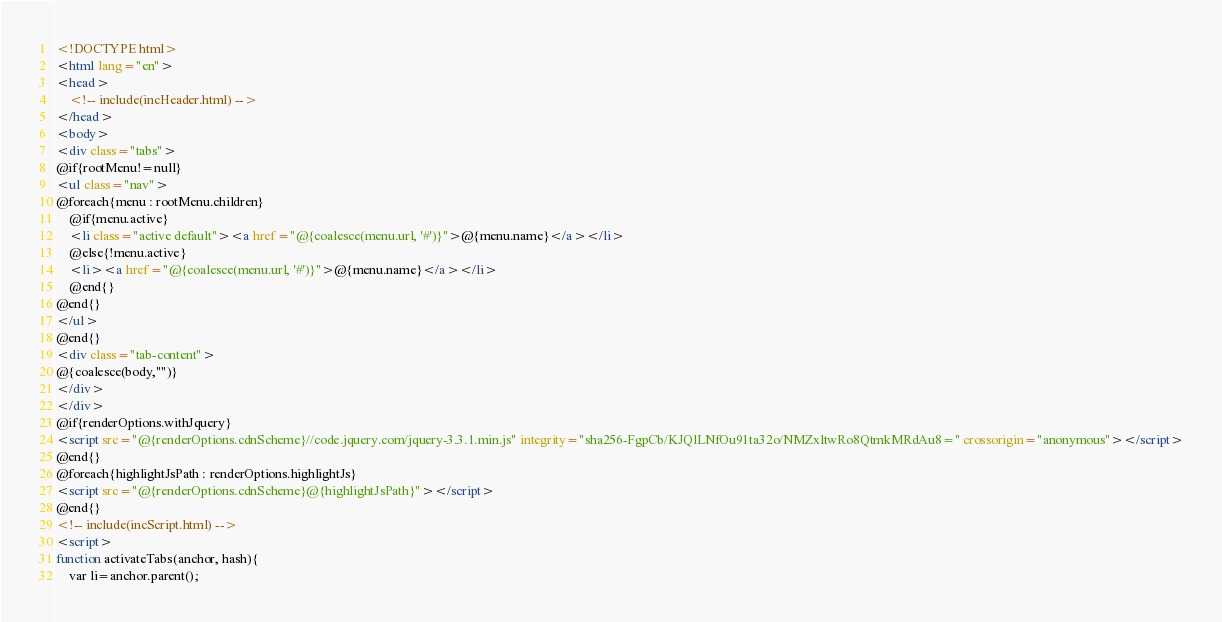Convert code to text. <code><loc_0><loc_0><loc_500><loc_500><_HTML_><!DOCTYPE html>
<html lang="en">
<head>
	<!-- include(incHeader.html) -->
</head>
<body>
<div class="tabs">
@if{rootMenu!=null}
<ul class="nav">
@foreach{menu : rootMenu.children}
	@if{menu.active}
	<li class="active default"><a href="@{coalesce(menu.url, '#')}">@{menu.name}</a></li>
	@else{!menu.active}
	<li><a href="@{coalesce(menu.url, '#')}">@{menu.name}</a></li>
	@end{}
@end{}
</ul>
@end{}
<div class="tab-content">
@{coalesce(body,"")}
</div>
</div>
@if{renderOptions.withJquery}
<script src="@{renderOptions.cdnScheme}//code.jquery.com/jquery-3.3.1.min.js" integrity="sha256-FgpCb/KJQlLNfOu91ta32o/NMZxltwRo8QtmkMRdAu8=" crossorigin="anonymous"></script>
@end{}
@foreach{highlightJsPath : renderOptions.highlightJs}
<script src="@{renderOptions.cdnScheme}@{highlightJsPath}"></script>
@end{}
<!-- include(incScript.html) -->
<script>
function activateTabs(anchor, hash){
	var li=anchor.parent();</code> 